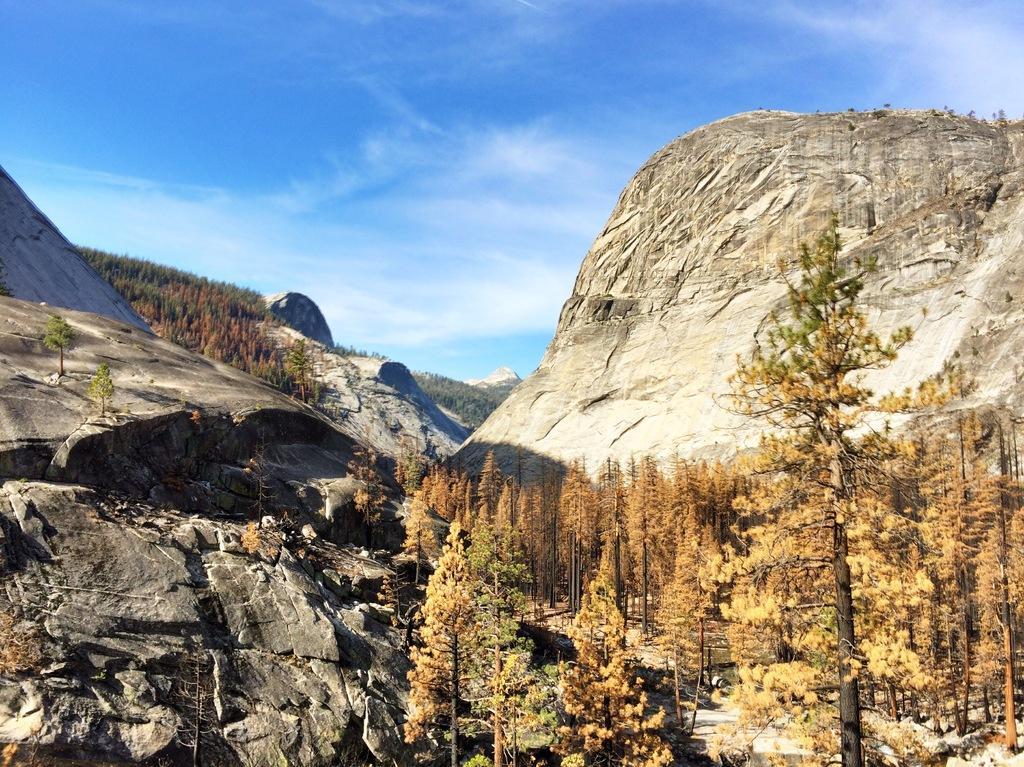Describe this image in one or two sentences. We can see trees and rocks and we can see sky with clouds. 